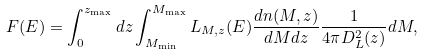Convert formula to latex. <formula><loc_0><loc_0><loc_500><loc_500>F ( E ) = \int _ { 0 } ^ { z _ { \max } } d z \int _ { M _ { \min } } ^ { M _ { \max } } L _ { M , z } ( E ) \frac { d n ( M , z ) } { d M d z } \frac { 1 } { 4 \pi D _ { L } ^ { 2 } ( z ) } d M ,</formula> 